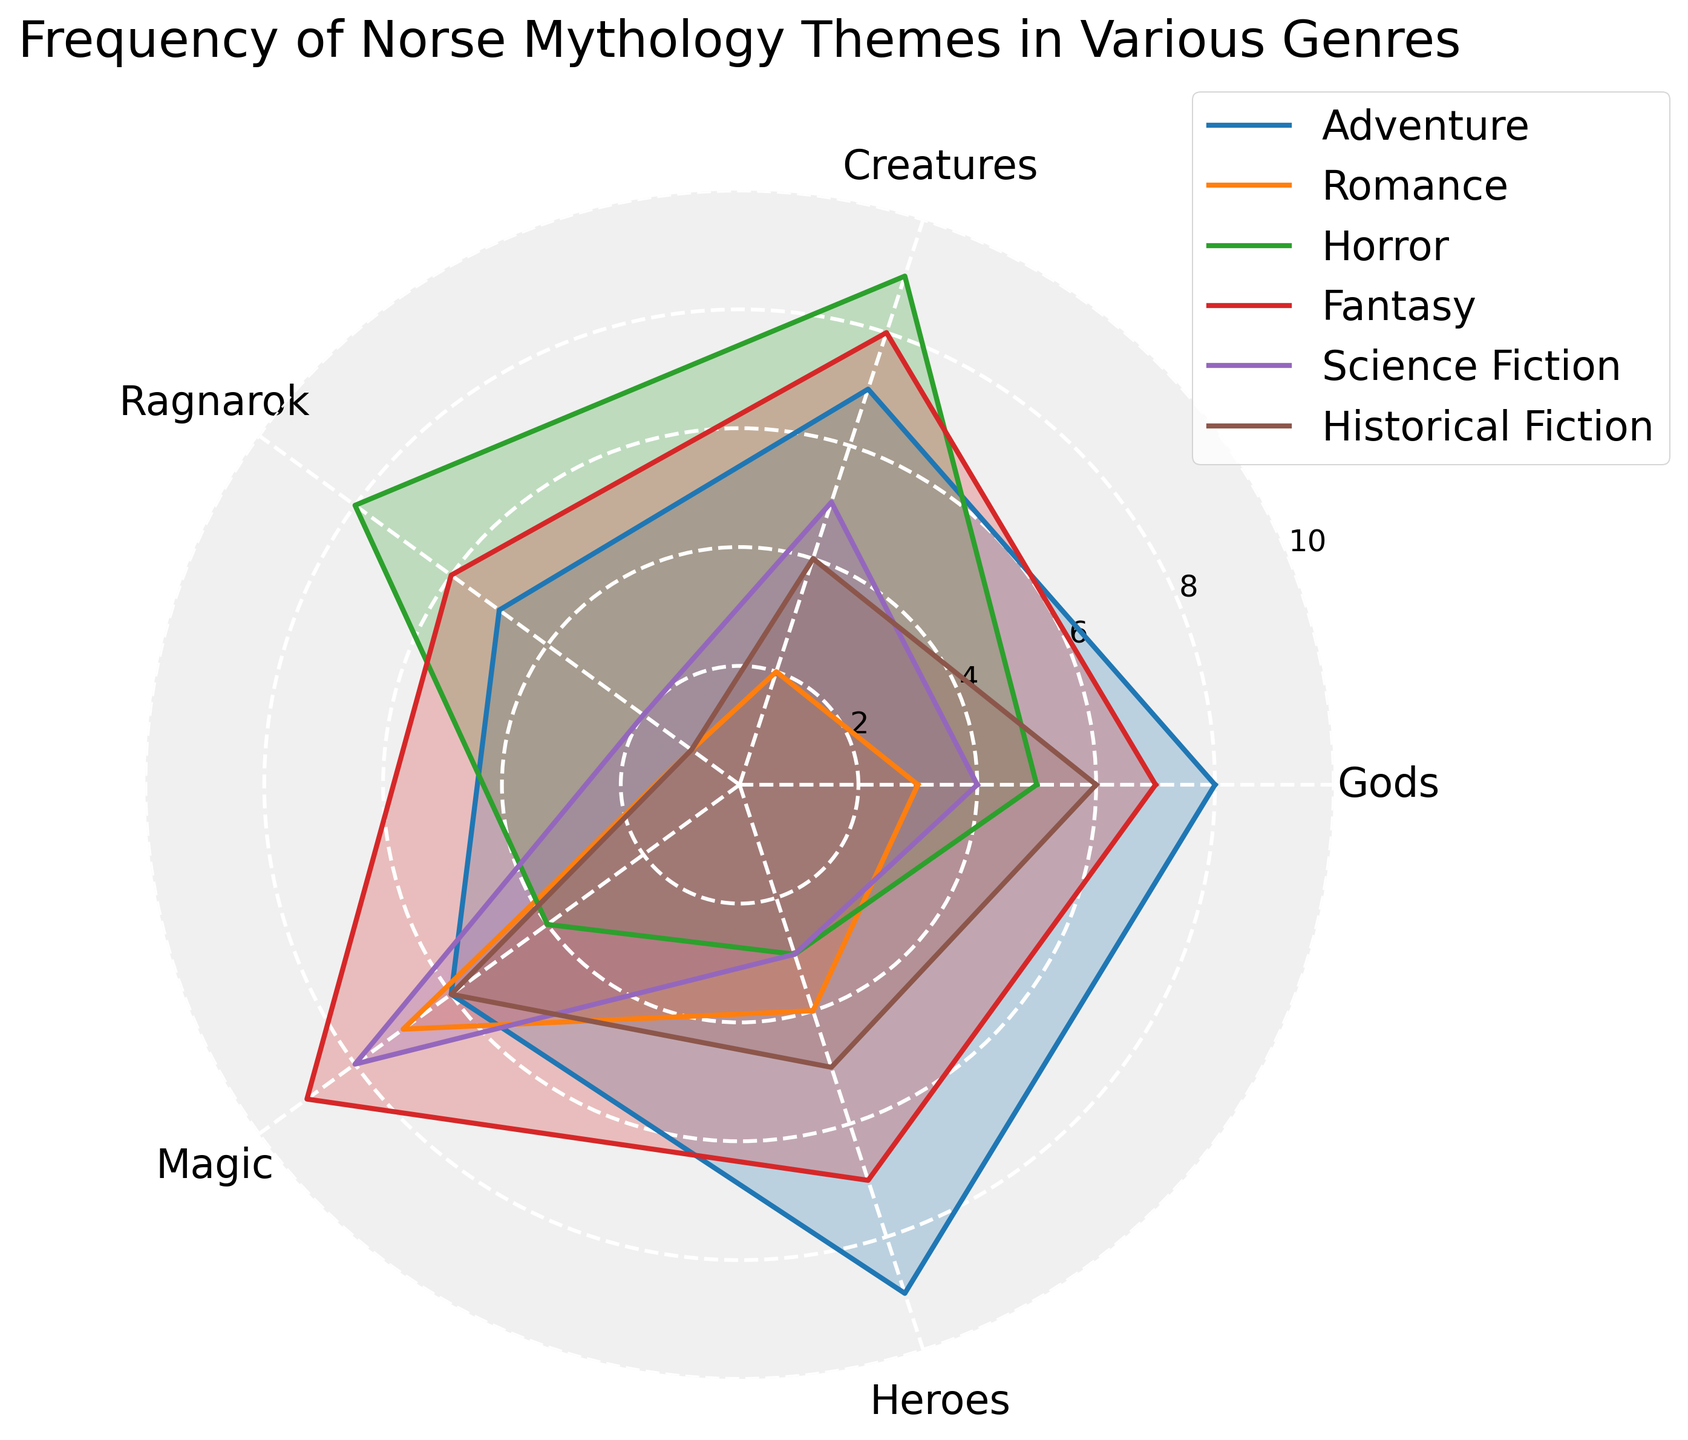Which genre has the highest frequency of the "Magic" theme? To find the genre with the highest frequency of the "Magic" theme, look at the data points along the "Magic" axis. Identify the genre with the highest value.
Answer: Fantasy Which theme is most frequently represented in Adventure novels? Look at the values for Adventure across all themes. Identify which theme has the highest value.
Answer: Heroes What's the difference in the frequency of "Creatures" between Horror and Romance? Identify the frequency values of the "Creatures" theme for both Horror and Romance. Subtract the Romance value from the Horror value: 9 - 2 = 7.
Answer: 7 Which genre features the "Ragnarok" theme the least? Find the lowest value for the "Ragnarok" theme across all genres. Identify the corresponding genre.
Answer: Romance What is the average frequency of all themes in Science Fiction? Sum all the frequencies for Science Fiction: 4 + 5 + 2 + 8 + 3 = 22. Divide by the number of themes: 22 / 5 = 4.4.
Answer: 4.4 Which genre has the most balanced distribution of frequencies across all themes? Observe the radar chart and find the genre whose values appear most evenly distributed across all axes. This typically means less variation between the highest and lowest values.
Answer: Historical Fiction How does the frequency of "Gods" in Adventure compare to Romance? Look at the frequencies of the "Gods" theme for both Adventure and Romance. Compare the values: 8 for Adventure and 3 for Romance; Adventure has a higher frequency.
Answer: Adventure is higher Which theme in Fantasy has the least frequency, and what is its value? Find the theme in Fantasy with the lowest value by inspecting all values of Fantasy across the themes. Identify both the theme and its corresponding value.
Answer: Gods, 7 